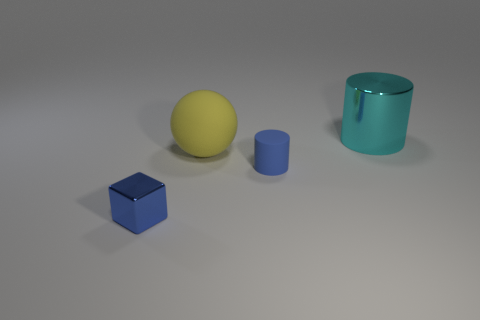What number of blue rubber objects are the same shape as the big cyan thing?
Offer a very short reply. 1. What is the shape of the other thing that is the same color as the small metallic object?
Keep it short and to the point. Cylinder. The other rubber thing that is the same size as the cyan object is what shape?
Make the answer very short. Sphere. Is the number of purple metallic cubes less than the number of tiny cylinders?
Provide a succinct answer. Yes. There is a cylinder in front of the cyan cylinder; is there a tiny blue thing that is in front of it?
Your answer should be very brief. Yes. What shape is the cyan thing that is the same material as the blue cube?
Make the answer very short. Cylinder. Are there any other things that are the same color as the large matte object?
Your answer should be very brief. No. There is another thing that is the same shape as the blue rubber thing; what is it made of?
Your answer should be very brief. Metal. What number of other objects are there of the same size as the sphere?
Your response must be concise. 1. There is a blue thing right of the matte sphere; is it the same shape as the cyan object?
Offer a very short reply. Yes. 